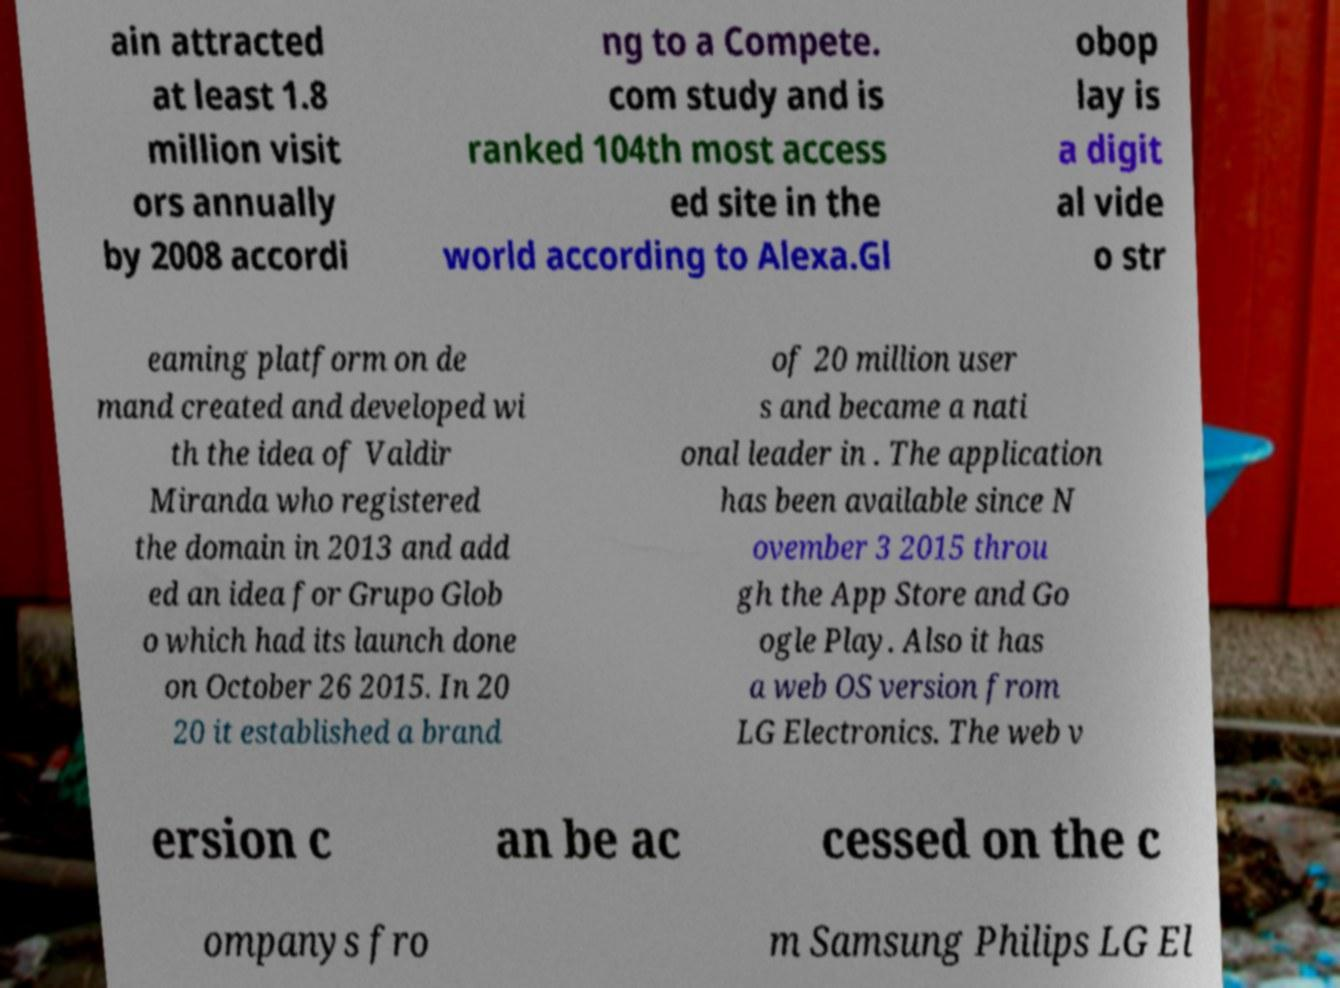Please identify and transcribe the text found in this image. ain attracted at least 1.8 million visit ors annually by 2008 accordi ng to a Compete. com study and is ranked 104th most access ed site in the world according to Alexa.Gl obop lay is a digit al vide o str eaming platform on de mand created and developed wi th the idea of Valdir Miranda who registered the domain in 2013 and add ed an idea for Grupo Glob o which had its launch done on October 26 2015. In 20 20 it established a brand of 20 million user s and became a nati onal leader in . The application has been available since N ovember 3 2015 throu gh the App Store and Go ogle Play. Also it has a web OS version from LG Electronics. The web v ersion c an be ac cessed on the c ompanys fro m Samsung Philips LG El 